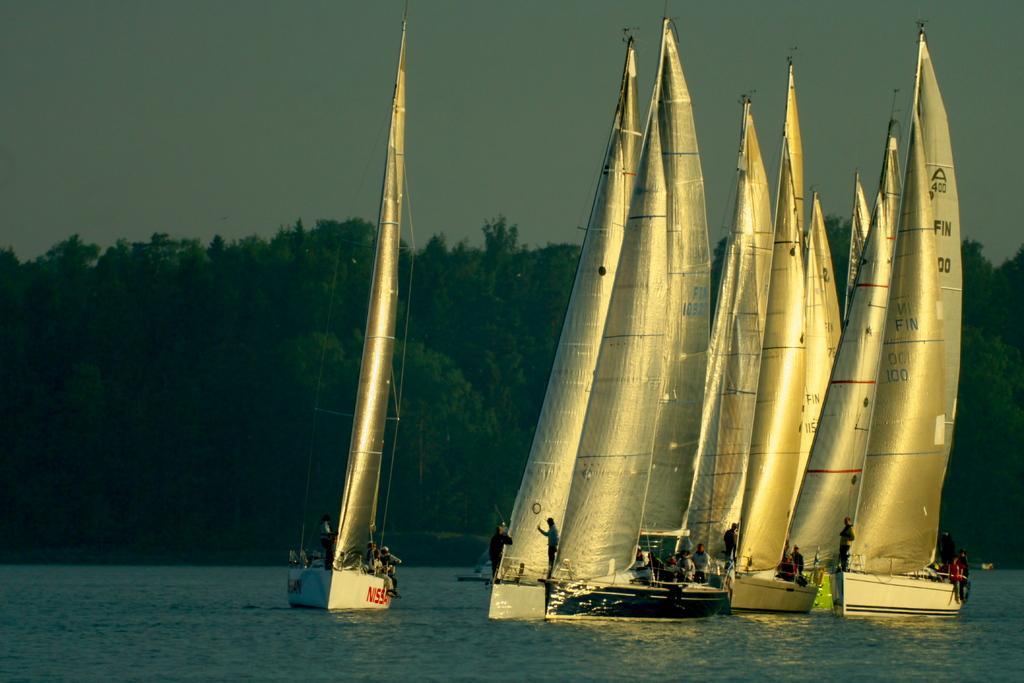In one or two sentences, can you explain what this image depicts? This is an outside view. In this image I can see many sailboats on the water. On the boats there are few people. In the background there are many trees. At the top of the image I can see the sky. 